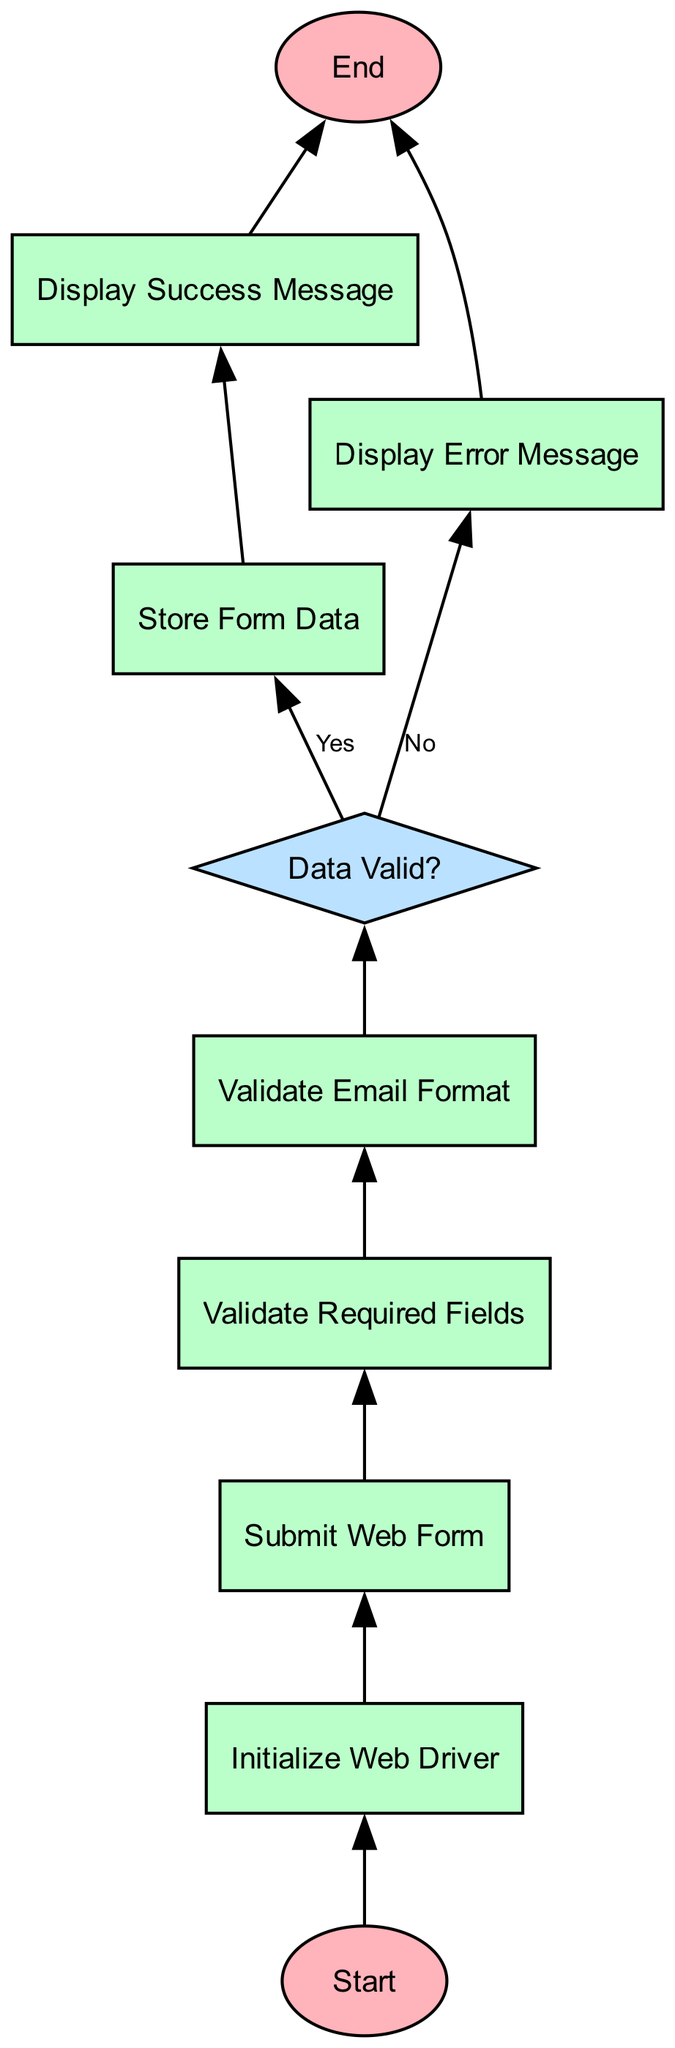What is the first process in the flowchart? The flowchart starts with the "Initialize Web Driver" process immediately after the "Start" terminator. This indicates that initializing the Selenium WebDriver is the first action taken in the flow.
Answer: Initialize Web Driver How many decision nodes are in the flowchart? The flowchart contains one decision node, which is "Data Valid?". This node assesses whether the submitted data meets the validation criteria, directing the flow based on the outcome.
Answer: 1 What message is displayed if the form data is valid? If the form data is validated successfully, the flowchart leads to the "Display Success Message" process, indicating that users receive a success notification.
Answer: Display Success Message What happens after the "Validate Email Format"? After validating email format, the flowchart proceeds to the "Data Valid?" decision node to check if the entire form data is valid. This logical step is crucial for determining the subsequent actions to take.
Answer: Data Valid? If the form data is invalid, which process follows? If the form data is deemed invalid, the flowchart indicates that the next step is to "Display Error Message". This action informs users about the validation failure, guiding them to make the necessary corrections.
Answer: Display Error Message What is the last step in the flowchart? The last step in the flowchart is the "End" terminator, which marks the conclusion of the function once all processes and decisions have been executed. This signifies the exit point from the flow.
Answer: End Which process comes immediately after "Submit Web Form"? Following "Submit Web Form", the flowchart progresses to "Validate Required Fields", indicating that the next action is to ensure all necessary fields have been completed before further validation.
Answer: Validate Required Fields What is checked after "Validate Required Fields"? After the "Validate Required Fields" process, the flowchart advances to "Validate Email Format", where the format of the user's email is specifically validated for correctness.
Answer: Validate Email Format 